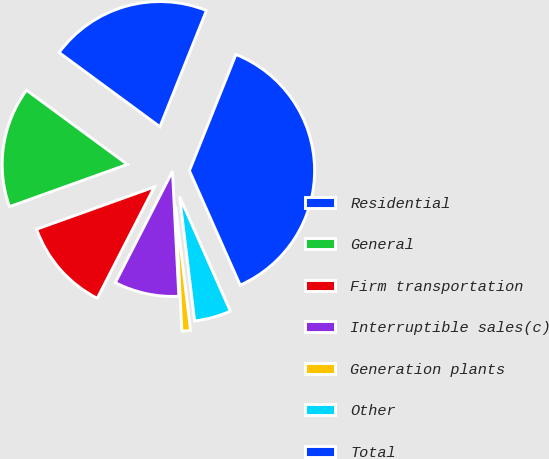<chart> <loc_0><loc_0><loc_500><loc_500><pie_chart><fcel>Residential<fcel>General<fcel>Firm transportation<fcel>Interruptible sales(c)<fcel>Generation plants<fcel>Other<fcel>Total<nl><fcel>20.96%<fcel>15.58%<fcel>11.97%<fcel>8.35%<fcel>1.11%<fcel>4.73%<fcel>37.29%<nl></chart> 